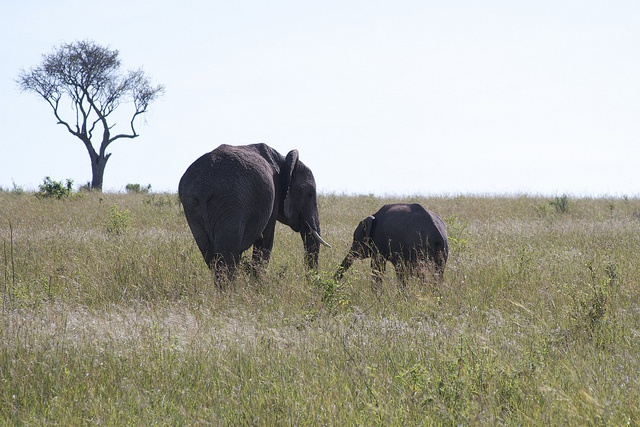Describe the objects in this image and their specific colors. I can see elephant in lavender, black, gray, and darkgray tones and elephant in lavender, black, gray, and darkgray tones in this image. 